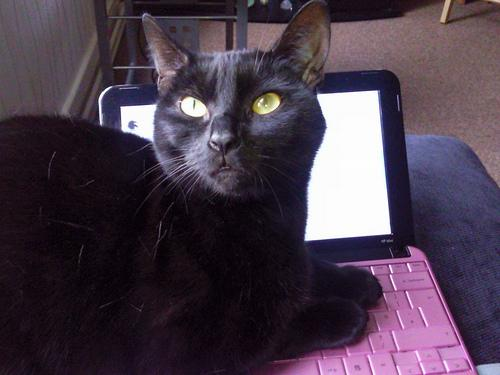Mention the type of furniture seen in the background and their specific details. There are metal and wooden chair legs, and a dark colored chair cushion. Can you enumerate the main features of the cat's face in the image? The cat has golden eyes, black ears, a nose, a mouth, and whiskers. Please count and describe the distinct colors of the cat's eyes. There are two cat eyes, colored silver and golden. Can you detect any emotional attribute from the cat in the image? The cat appears to be attentively looking at the camera. How would you sum up the overall mood and tone of the image? The image has a calm and curious vibe, with the cat engaging attentively on a laptop. Describe how easy or hard it is to distinguish objects in the image. The image quality seems adequate for identifying the various objects present. What is the primary object present in the image and its primary actions? A black cat is sitting on a powered-on netbook. What is the surface surrounding the laptop like? Explain its characteristics. The laptop is on a light brown short carpet. How many legs are visible on the cat, and what are they doing? There are two visible cat legs, seemingly relaxed on the laptop. Identify the different parts of the laptop and describe their appearance. The laptop has a black frame on screen, a powered-on screen, a pink keyboard, top, and bottom. Read the text on the key of the keyboard. No text is visible in the image. Describe the position of the black cat in relation to the netbook. The black cat is sitting on the netbook. What activity is the cat participating in? Sitting on the netbook List three colors mentioned in the scene. Black (cat), pink (keyboard buttons), and light brown (carpet) What is the color of the carpet? Light brown What type of material makes up the chair leg in the background? Wood In the image, note the open window with blue curtains near the furniture. Did you see it? No, it's not mentioned in the image. Explain the relation between the wooden chair leg and the metal furniture legs. The wooden chair leg is in the background, while the metal furniture legs are behind the cat. In a haiku format, describe the cat and the laptop. Black cat sits still What does the color of the laptop keyboard buttons suggest? They are pink, possibly designed for style or attracting a specific user base. Describe the cat's position with old English styled language. Yon ebony feline doth repose upon ye illuminated contraption of modernity. Identify the event taking place in the image. A cat sitting on a powered-on netbook Is the whisker area of the cat visible in the image? Yes Identify the object described by "pink keyboard on netbook." The laptop's keyboard What color are the cat's eyes? Golden Using poetic language, describe the scene with the cat and the netbook. A shadowy feline perches atop a glowing electronic device, surrounded by the soft embrace of an earth-toned carpet. Which object is closer to the cat: the wooden chair leg, or the metal furniture legs? Metal furniture legs Determine the object referred to by "the bottom of the laptop." The lower part of the open netbook 